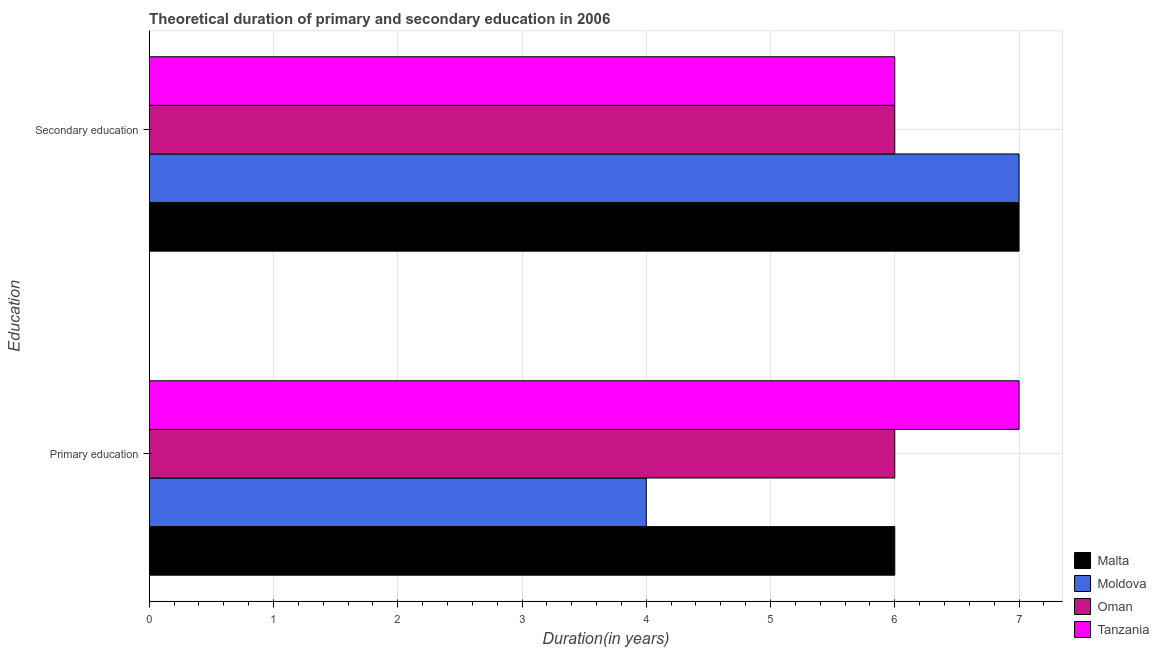How many different coloured bars are there?
Ensure brevity in your answer.  4. Are the number of bars per tick equal to the number of legend labels?
Your answer should be compact. Yes. Are the number of bars on each tick of the Y-axis equal?
Keep it short and to the point. Yes. What is the duration of secondary education in Moldova?
Offer a very short reply. 7. Across all countries, what is the maximum duration of primary education?
Provide a succinct answer. 7. Across all countries, what is the minimum duration of primary education?
Your response must be concise. 4. In which country was the duration of primary education maximum?
Offer a terse response. Tanzania. In which country was the duration of primary education minimum?
Make the answer very short. Moldova. What is the total duration of secondary education in the graph?
Offer a terse response. 26. What is the difference between the duration of primary education in Tanzania and the duration of secondary education in Malta?
Offer a very short reply. 0. What is the average duration of secondary education per country?
Provide a short and direct response. 6.5. What is the difference between the duration of secondary education and duration of primary education in Tanzania?
Your response must be concise. -1. Is the duration of primary education in Moldova less than that in Oman?
Offer a terse response. Yes. What does the 4th bar from the top in Secondary education represents?
Give a very brief answer. Malta. What does the 4th bar from the bottom in Primary education represents?
Your response must be concise. Tanzania. How many bars are there?
Give a very brief answer. 8. Are all the bars in the graph horizontal?
Keep it short and to the point. Yes. How many countries are there in the graph?
Offer a terse response. 4. What is the difference between two consecutive major ticks on the X-axis?
Give a very brief answer. 1. Does the graph contain grids?
Keep it short and to the point. Yes. Where does the legend appear in the graph?
Your response must be concise. Bottom right. How many legend labels are there?
Provide a succinct answer. 4. How are the legend labels stacked?
Your answer should be compact. Vertical. What is the title of the graph?
Your response must be concise. Theoretical duration of primary and secondary education in 2006. What is the label or title of the X-axis?
Provide a short and direct response. Duration(in years). What is the label or title of the Y-axis?
Your answer should be very brief. Education. What is the Duration(in years) in Moldova in Primary education?
Your answer should be very brief. 4. What is the Duration(in years) in Tanzania in Primary education?
Provide a short and direct response. 7. What is the Duration(in years) in Tanzania in Secondary education?
Provide a succinct answer. 6. Across all Education, what is the maximum Duration(in years) of Malta?
Provide a succinct answer. 7. Across all Education, what is the maximum Duration(in years) in Moldova?
Your answer should be compact. 7. Across all Education, what is the maximum Duration(in years) of Tanzania?
Make the answer very short. 7. Across all Education, what is the minimum Duration(in years) of Moldova?
Your answer should be very brief. 4. Across all Education, what is the minimum Duration(in years) of Oman?
Give a very brief answer. 6. What is the total Duration(in years) of Moldova in the graph?
Offer a very short reply. 11. What is the total Duration(in years) in Tanzania in the graph?
Ensure brevity in your answer.  13. What is the difference between the Duration(in years) in Malta in Primary education and that in Secondary education?
Ensure brevity in your answer.  -1. What is the difference between the Duration(in years) in Oman in Primary education and that in Secondary education?
Provide a succinct answer. 0. What is the difference between the Duration(in years) in Malta in Primary education and the Duration(in years) in Moldova in Secondary education?
Give a very brief answer. -1. What is the difference between the Duration(in years) in Malta in Primary education and the Duration(in years) in Oman in Secondary education?
Your answer should be very brief. 0. What is the difference between the Duration(in years) of Malta in Primary education and the Duration(in years) of Tanzania in Secondary education?
Provide a short and direct response. 0. What is the difference between the Duration(in years) of Moldova in Primary education and the Duration(in years) of Oman in Secondary education?
Provide a short and direct response. -2. What is the difference between the Duration(in years) of Oman in Primary education and the Duration(in years) of Tanzania in Secondary education?
Offer a terse response. 0. What is the average Duration(in years) of Malta per Education?
Ensure brevity in your answer.  6.5. What is the average Duration(in years) of Tanzania per Education?
Your response must be concise. 6.5. What is the difference between the Duration(in years) in Malta and Duration(in years) in Moldova in Primary education?
Your answer should be very brief. 2. What is the difference between the Duration(in years) of Moldova and Duration(in years) of Tanzania in Primary education?
Provide a short and direct response. -3. What is the difference between the Duration(in years) of Oman and Duration(in years) of Tanzania in Primary education?
Make the answer very short. -1. What is the difference between the Duration(in years) of Malta and Duration(in years) of Moldova in Secondary education?
Keep it short and to the point. 0. What is the difference between the Duration(in years) in Moldova and Duration(in years) in Tanzania in Secondary education?
Offer a very short reply. 1. What is the difference between the Duration(in years) of Oman and Duration(in years) of Tanzania in Secondary education?
Offer a very short reply. 0. What is the ratio of the Duration(in years) of Moldova in Primary education to that in Secondary education?
Keep it short and to the point. 0.57. What is the ratio of the Duration(in years) in Oman in Primary education to that in Secondary education?
Your response must be concise. 1. What is the difference between the highest and the second highest Duration(in years) in Moldova?
Your answer should be compact. 3. What is the difference between the highest and the second highest Duration(in years) of Oman?
Give a very brief answer. 0. What is the difference between the highest and the lowest Duration(in years) of Malta?
Keep it short and to the point. 1. What is the difference between the highest and the lowest Duration(in years) of Moldova?
Ensure brevity in your answer.  3. What is the difference between the highest and the lowest Duration(in years) in Oman?
Give a very brief answer. 0. What is the difference between the highest and the lowest Duration(in years) in Tanzania?
Your answer should be compact. 1. 